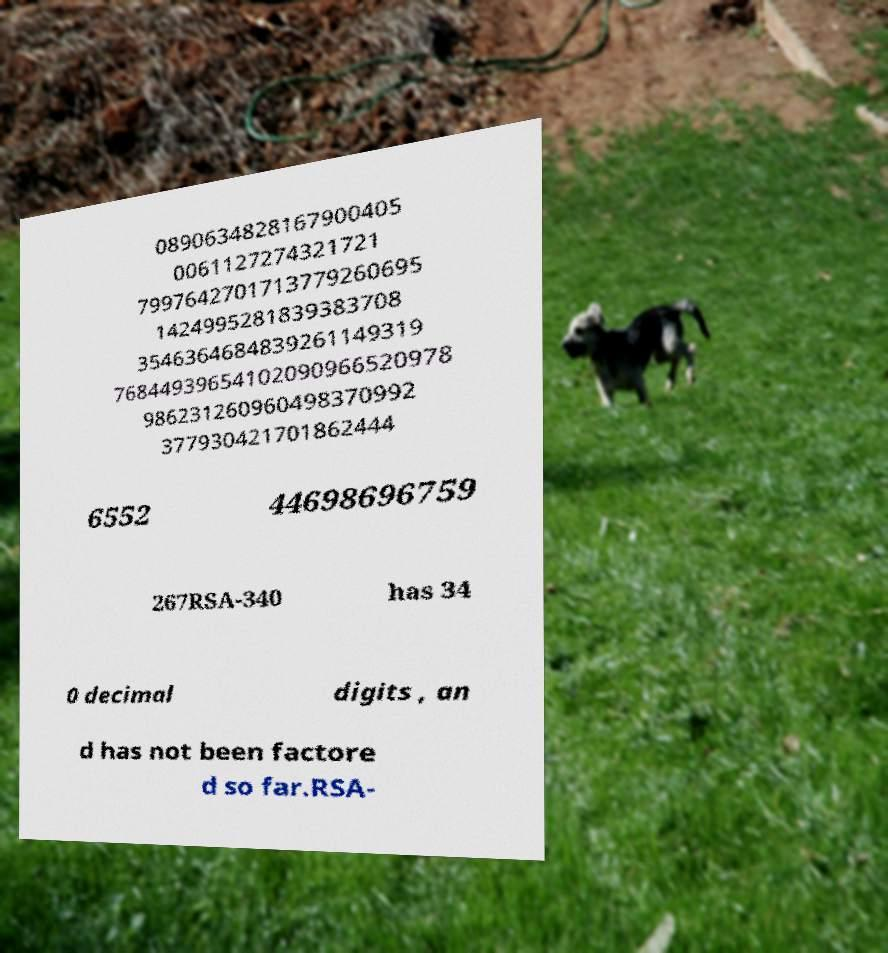Could you assist in decoding the text presented in this image and type it out clearly? 0890634828167900405 0061127274321721 7997642701713779260695 1424995281839383708 3546364684839261149319 76844939654102090966520978 986231260960498370992 377930421701862444 6552 44698696759 267RSA-340 has 34 0 decimal digits , an d has not been factore d so far.RSA- 